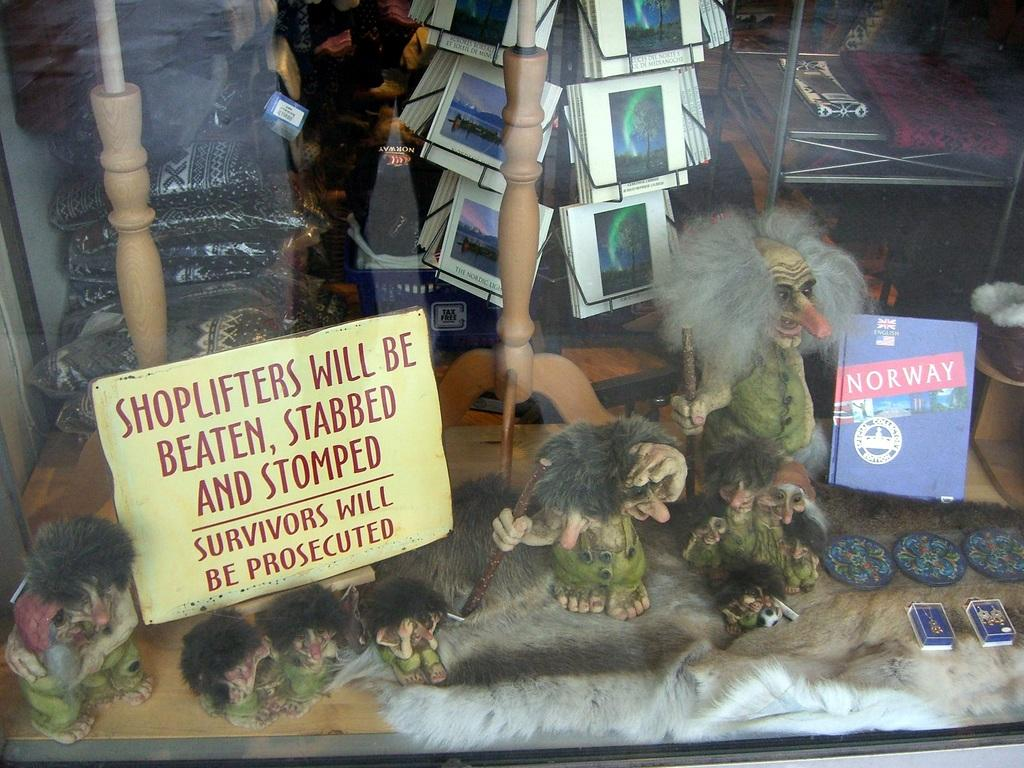<image>
Give a short and clear explanation of the subsequent image. a store front display case with a sign about SHOPLIFTERS 